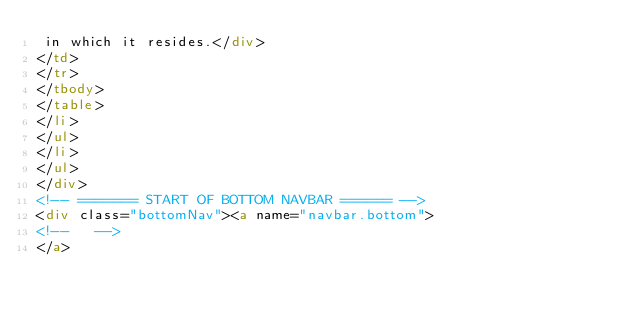<code> <loc_0><loc_0><loc_500><loc_500><_HTML_> in which it resides.</div>
</td>
</tr>
</tbody>
</table>
</li>
</ul>
</li>
</ul>
</div>
<!-- ======= START OF BOTTOM NAVBAR ====== -->
<div class="bottomNav"><a name="navbar.bottom">
<!--   -->
</a></code> 